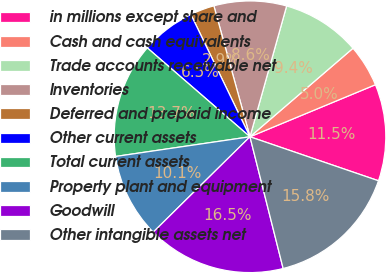<chart> <loc_0><loc_0><loc_500><loc_500><pie_chart><fcel>in millions except share and<fcel>Cash and cash equivalents<fcel>Trade accounts receivable net<fcel>Inventories<fcel>Deferred and prepaid income<fcel>Other current assets<fcel>Total current assets<fcel>Property plant and equipment<fcel>Goodwill<fcel>Other intangible assets net<nl><fcel>11.51%<fcel>5.04%<fcel>9.35%<fcel>8.63%<fcel>2.88%<fcel>6.48%<fcel>13.67%<fcel>10.07%<fcel>16.54%<fcel>15.82%<nl></chart> 